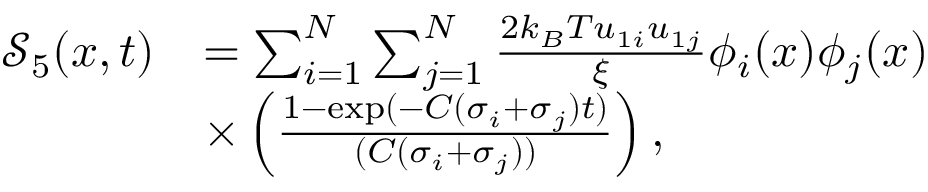Convert formula to latex. <formula><loc_0><loc_0><loc_500><loc_500>\begin{array} { r l } { \mathcal { S } _ { 5 } ( x , t ) } & { = \sum _ { i = 1 } ^ { N } \sum _ { j = 1 } ^ { N } \frac { 2 k _ { B } T u _ { 1 i } u _ { 1 j } } { \xi } \phi _ { i } ( x ) \phi _ { j } ( x ) } \\ & { \times \left ( \frac { 1 - \exp ( - C ( \sigma _ { i } + \sigma _ { j } ) t ) } { ( C ( \sigma _ { i } + \sigma _ { j } ) ) } \right ) , } \end{array}</formula> 